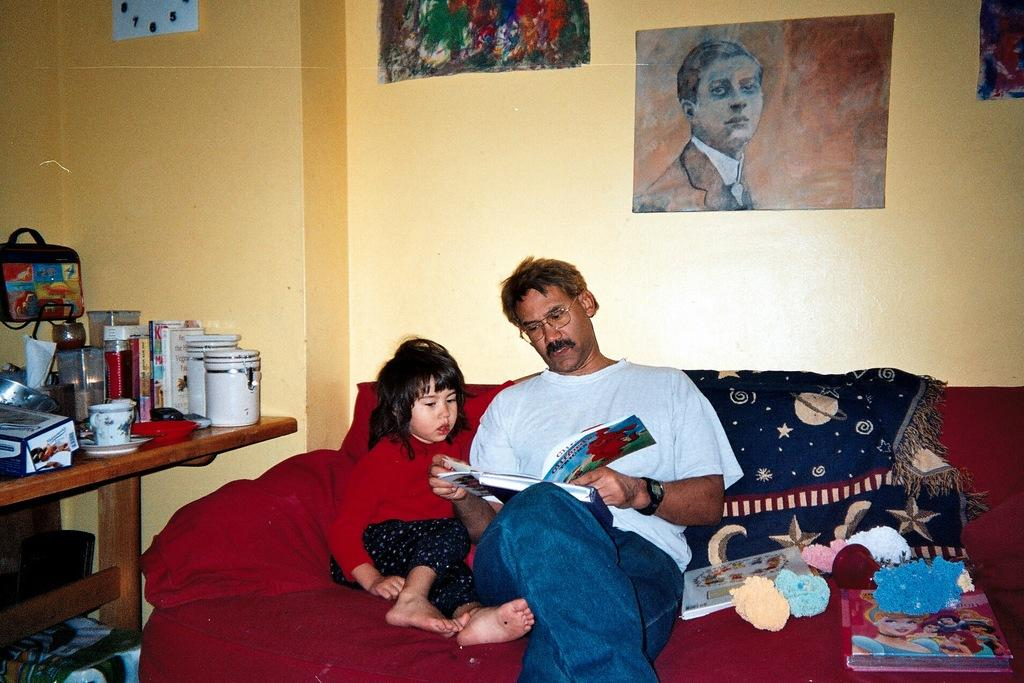How many people are sitting on the couch in the image? There are two persons sitting on a couch in the image. What can be seen in the image besides the couch? There is a table in the image. What is on the table in the image? There are objects on the table. What is visible in the background of the image? There is a wall in the background of the image. What type of sail can be seen in the image? There is no sail present in the image. What kind of lettuce is being served on the table in the image? There is no lettuce visible in the image; it only shows objects on the table. 